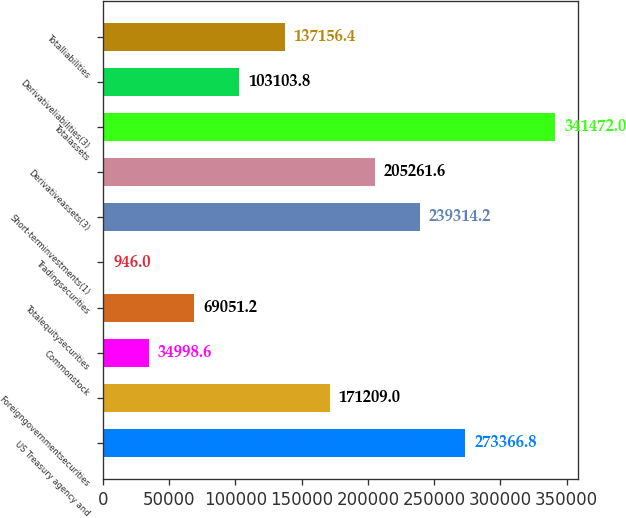Convert chart. <chart><loc_0><loc_0><loc_500><loc_500><bar_chart><fcel>US Treasury agency and<fcel>Foreigngovernmentsecurities<fcel>Commonstock<fcel>Totalequitysecurities<fcel>Tradingsecurities<fcel>Short-terminvestments(1)<fcel>Derivativeassets(3)<fcel>Totalassets<fcel>Derivativeliabilities(3)<fcel>Totalliabilities<nl><fcel>273367<fcel>171209<fcel>34998.6<fcel>69051.2<fcel>946<fcel>239314<fcel>205262<fcel>341472<fcel>103104<fcel>137156<nl></chart> 